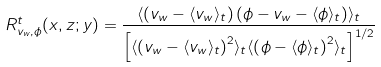<formula> <loc_0><loc_0><loc_500><loc_500>R _ { v _ { w } , \phi } ^ { t } ( x , z ; y ) = \frac { \langle \left ( v _ { w } - \langle v _ { w } \rangle _ { t } \right ) \left ( \phi - v _ { w } - \langle \phi \rangle _ { t } \right ) \rangle _ { t } } { \left [ \langle \left ( v _ { w } - \langle v _ { w } \rangle _ { t } \right ) ^ { 2 } \rangle _ { t } \langle \left ( \phi - \langle \phi \rangle _ { t } \right ) ^ { 2 } \rangle _ { t } \right ] ^ { 1 / 2 } }</formula> 